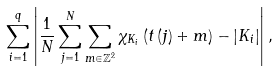Convert formula to latex. <formula><loc_0><loc_0><loc_500><loc_500>\sum _ { i = 1 } ^ { q } \left | \frac { 1 } { N } \sum _ { j = 1 } ^ { N } \sum _ { m \in \mathbb { Z } ^ { 2 } } \chi _ { K _ { i } } \left ( t \left ( j \right ) + m \right ) - \left | K _ { i } \right | \right | ,</formula> 